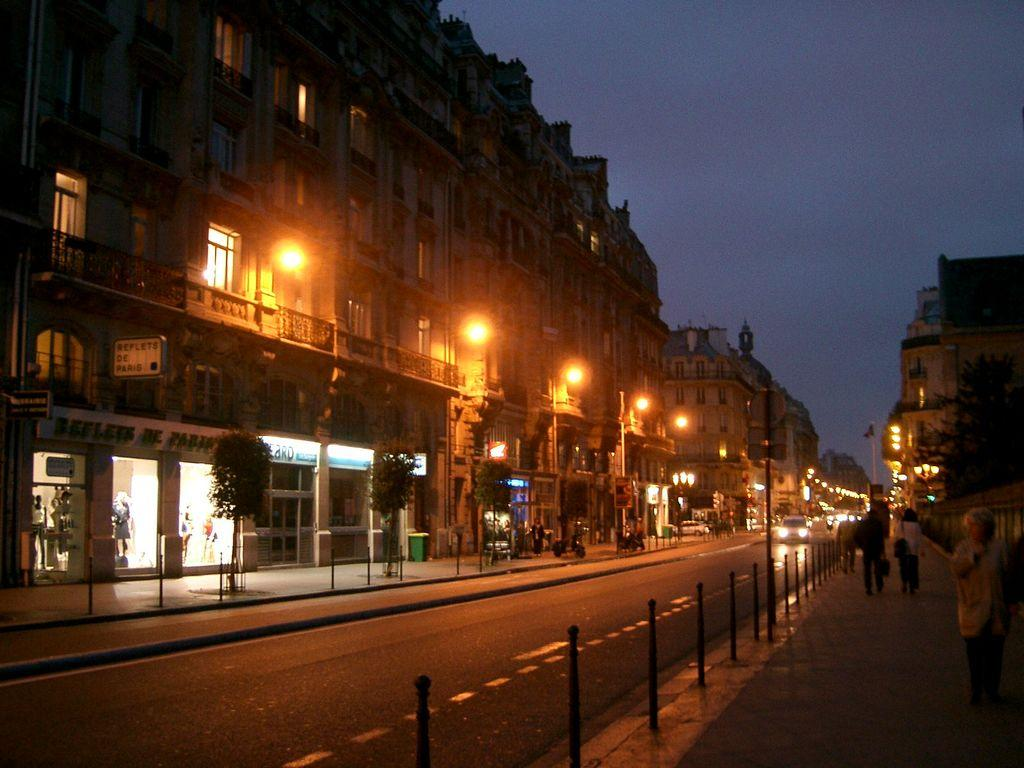What is the main feature of the picture? There is a road in the picture. What is happening on the road? There are vehicles moving on the road. What else can be seen in the picture besides the road and vehicles? There are poles and plants in the picture. How would you describe the weather in the picture? The sky is clear in the picture, suggesting good weather. What historical discovery was made by the explorers on their voyage in the picture? There are no explorers or any indication of a voyage in the picture; it simply shows a road with vehicles and other elements. 